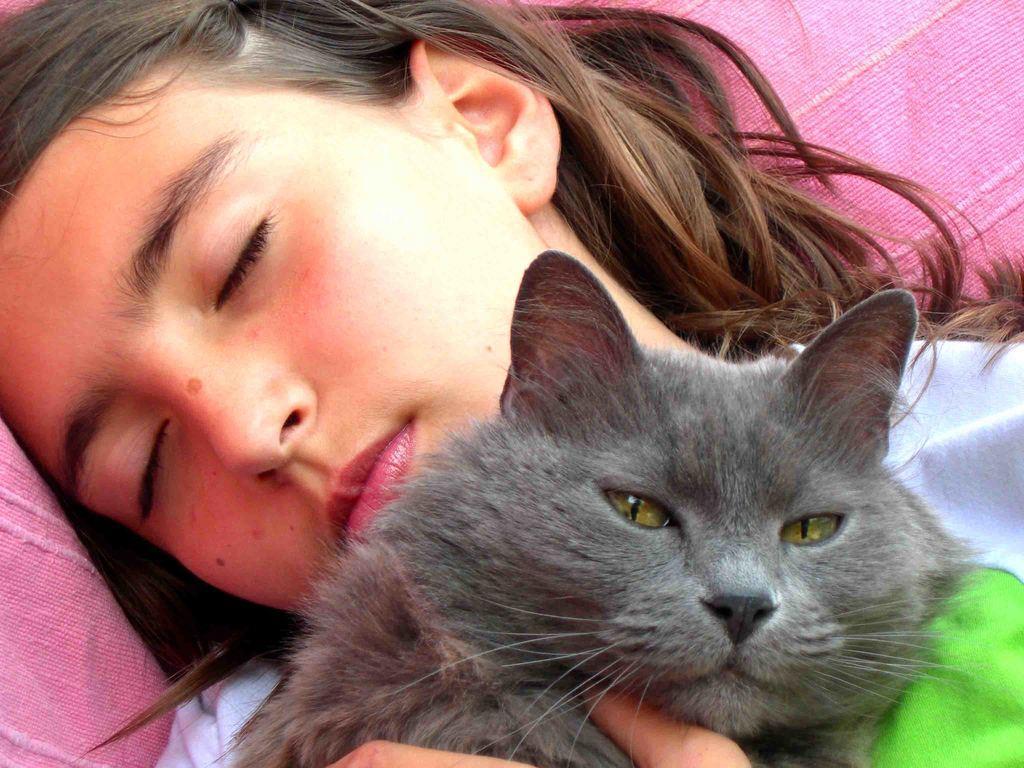Can you describe this image briefly? A lady with white and green t-shirt is sleeping by holding a black cat in her hand. In the background there is a pink cloth. 